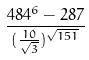<formula> <loc_0><loc_0><loc_500><loc_500>\frac { 4 8 4 ^ { 6 } - 2 8 7 } { ( \frac { 1 0 } { \sqrt { 3 } } ) ^ { \sqrt { 1 5 1 } } }</formula> 